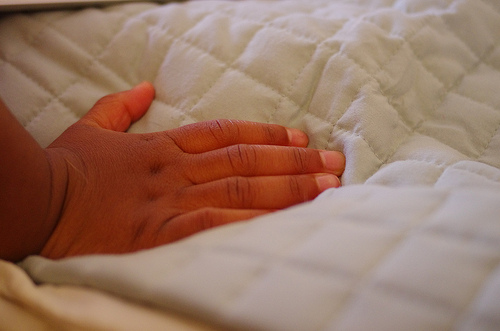<image>
Is there a fifth nail under the comforter? No. The fifth nail is not positioned under the comforter. The vertical relationship between these objects is different. 